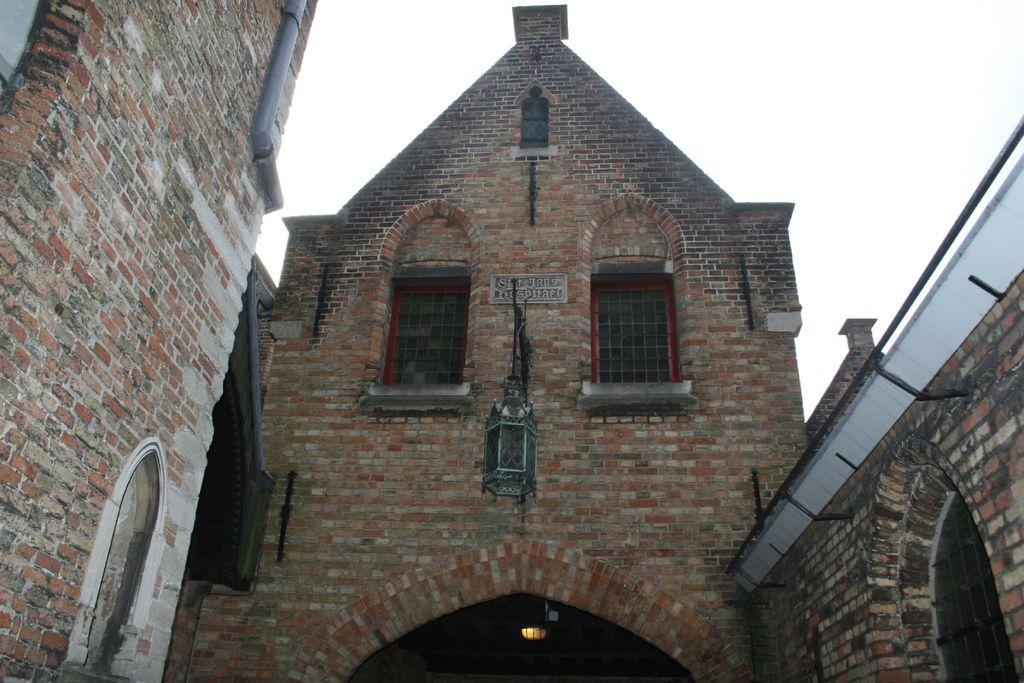What type of walls are visible in the image? There are brick walls in the image. What type of windows are visible in the image? There are glass windows in the image. What type of structural elements are visible in the image? There are rods and a pipe visible in the image. What type of illumination is visible in the image? There is a light in the image. What type of object is visible in the image? There is an object in the image. What can be seen in the background of the image? The sky is visible in the background of the image. What type of trade is being conducted in the image? There is no indication of any trade being conducted in the image. How does the band perform in the image? There is no band present in the image. 